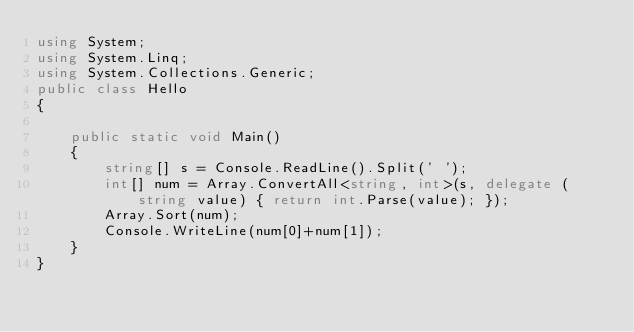<code> <loc_0><loc_0><loc_500><loc_500><_C#_>using System;
using System.Linq;
using System.Collections.Generic;
public class Hello
{

    public static void Main()
    {
        string[] s = Console.ReadLine().Split(' ');
        int[] num = Array.ConvertAll<string, int>(s, delegate (string value) { return int.Parse(value); });
        Array.Sort(num);
        Console.WriteLine(num[0]+num[1]);
    }
}</code> 